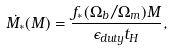<formula> <loc_0><loc_0><loc_500><loc_500>\dot { M _ { * } } ( M ) = \frac { f _ { * } ( \Omega _ { b } / \Omega _ { m } ) M } { \epsilon _ { d u t y } t _ { H } } ,</formula> 